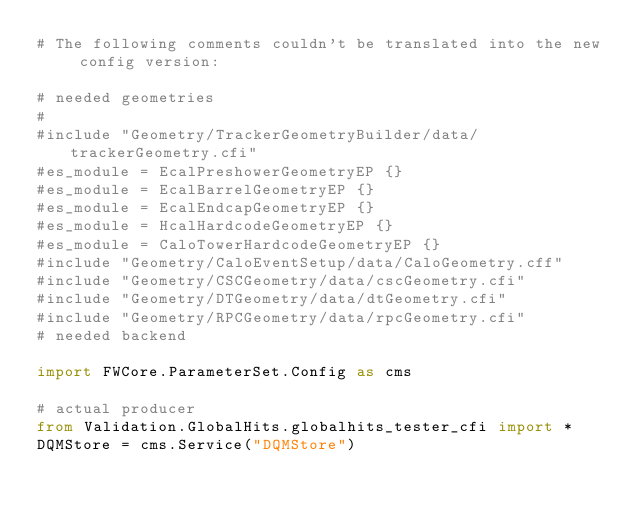Convert code to text. <code><loc_0><loc_0><loc_500><loc_500><_Python_># The following comments couldn't be translated into the new config version:

# needed geometries
#
#include "Geometry/TrackerGeometryBuilder/data/trackerGeometry.cfi"
#es_module = EcalPreshowerGeometryEP {}
#es_module = EcalBarrelGeometryEP {}
#es_module = EcalEndcapGeometryEP {}
#es_module = HcalHardcodeGeometryEP {}
#es_module = CaloTowerHardcodeGeometryEP {}
#include "Geometry/CaloEventSetup/data/CaloGeometry.cff"
#include "Geometry/CSCGeometry/data/cscGeometry.cfi"
#include "Geometry/DTGeometry/data/dtGeometry.cfi"
#include "Geometry/RPCGeometry/data/rpcGeometry.cfi"
# needed backend

import FWCore.ParameterSet.Config as cms

# actual producer
from Validation.GlobalHits.globalhits_tester_cfi import *
DQMStore = cms.Service("DQMStore")


</code> 